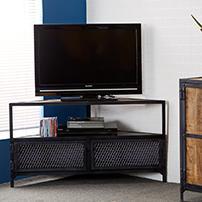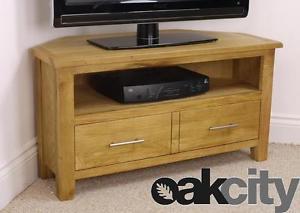The first image is the image on the left, the second image is the image on the right. Considering the images on both sides, is "Both TVs have black frames." valid? Answer yes or no. Yes. The first image is the image on the left, the second image is the image on the right. Assess this claim about the two images: "The legs of one media stand is made of metal.". Correct or not? Answer yes or no. Yes. 